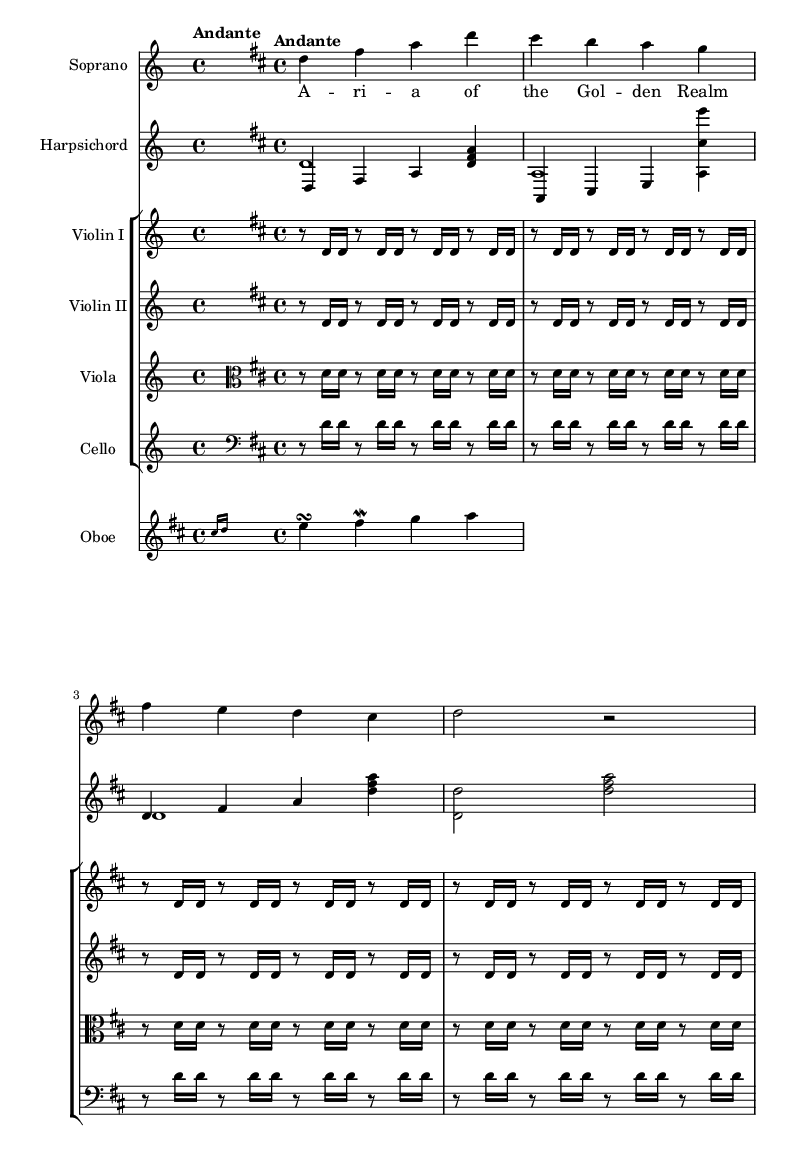What is the key signature of this music? The key signature shown in the music indicates D major, which has two sharps (F♯ and C♯). This is affirmed by the presence of these sharps in the notation of the score.
Answer: D major What is the time signature of this piece? The time signature is shown at the beginning of the score, marked as 4/4. This indicates that there are four beats in a measure and the quarter note gets one beat.
Answer: 4/4 What is the tempo marking for this music? The tempo marking is indicated in text as “Andante,” which suggests a moderately slow tempo, typically between 76 and 108 beats per minute.
Answer: Andante Which instrument plays the melody in the first line? The soprano is the instrument that plays the melody in the first line of the score, indicated by its staff and the notes corresponding to the lyrics provided.
Answer: Soprano How many instruments are present in this score? The score includes five distinct instruments: Soprano, Harpsichord, Violin I, Violin II, Viola, Cello, and Oboe. These instruments are grouped and labeled accordingly in the score layout.
Answer: Seven In which musical period was this piece likely composed? This piece likely belongs to the Baroque period, which is characterized by elaborate musical ornamentation, and typically features operatic forms, which is evident in the style and complexity shown in the score.
Answer: Baroque What is the function of the harpsichord in this score? The harpsichord serves as both a harmonic and rhythmic foundation, providing chords and accompaniment to the vocal and instrumental lines, typical of the Baroque style where it acted as a continuo instrument.
Answer: Continuo 